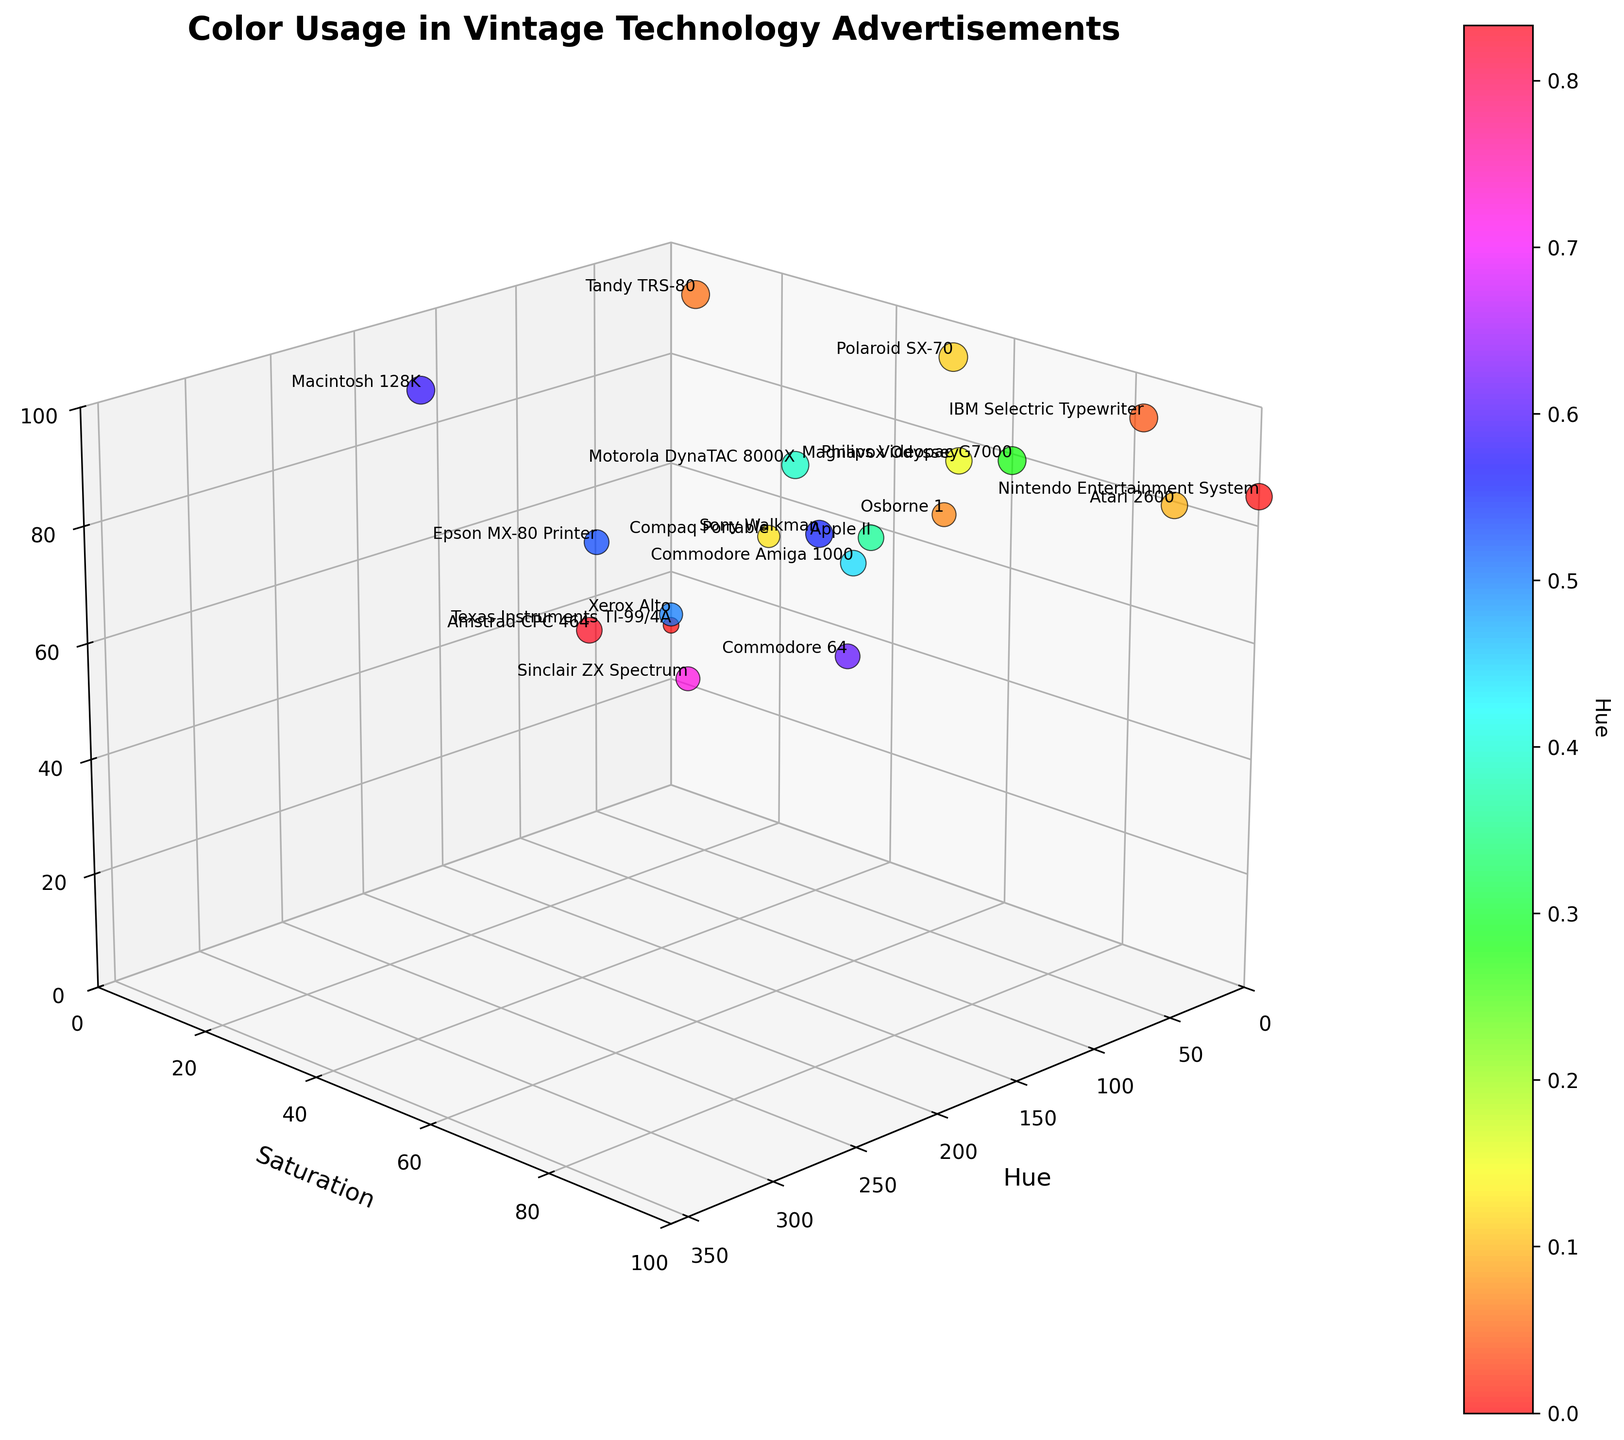What is the title of the figure? The title can be found at the top of the figure. It describes what the data is about.
Answer: Color Usage in Vintage Technology Advertisements Which product has the highest brightness value? Locate the highest point on the brightness axis and check its label.
Answer: Polaroid SX-70 How many products have a saturation value of exactly 100? Count the data points that touch the 100 mark on the saturation axis, looking at their labels.
Answer: 1 Which hue has the most products with brightness above 90? Count data points grouped by hue that have brightness values above 90 and find the hue with the highest count.
Answer: Multiple hues (0, 15, 15, 20, etc.); each has 2 What is the product with the lowest saturation and brightness values? Find the point at the lowest end on both the saturation and brightness axes and read its label.
Answer: Texas Instruments TI-99/4A What is the average brightness of products with a hue greater than 200? Identify the data points where hue is above 200, sum their brightness values, and divide by the number of these products. There are 4 such points: (Commodore 64, Amstrad CPC 464, Sinclair ZX Spectrum, and Macintosh 128K), their Brightness values: 75, 80, 70, and 95. Sum = 320, Average = 320/4
Answer: 80 Which products have a hue value between 0 and 50 and brightness above 80? Identify the points within the hue range of 0-50, and check which among them have brightness over 80.
Answer: IBM Selectric Typewriter, Atari 2600, Magnavox Odyssey, Osborne 1, Tandy TRS-80 Compare the saturation values of Sony Walkman and Commodore Amiga 1000. Which is higher? Locate both products on the graph, compare their positions along the saturation axis.
Answer: Sony Walkman Which product with a hue above 200 has the highest brightness? Filter the products by hue above 200, then find the one with the highest brightness value.
Answer: Macintosh 128K What is the median value of brightness for products with saturation below 50? Identify all products with saturation under 50, list their brightness values, and find the median. The products and brightness values: Texas Instruments TI-99/4A (30), Tandy TRS-80 (95), Epson MX-80 Printer (75), Compaq Portable (60), Macintosh 128K (95).
Answer: 75 